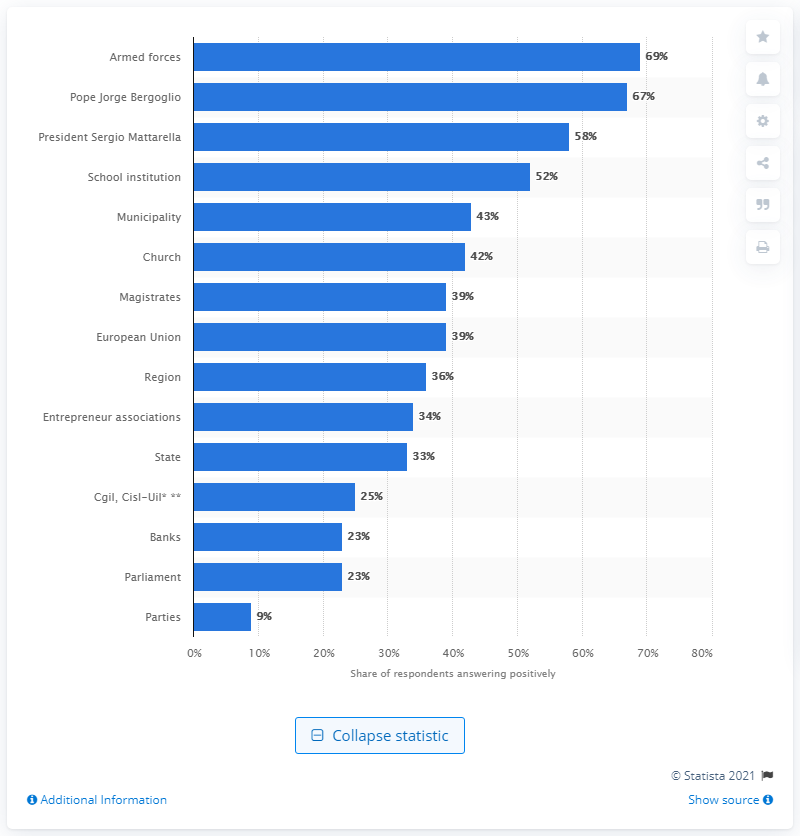Identify some key points in this picture. According to a recent survey, only 23% of Italians trust political parties and parliament. 